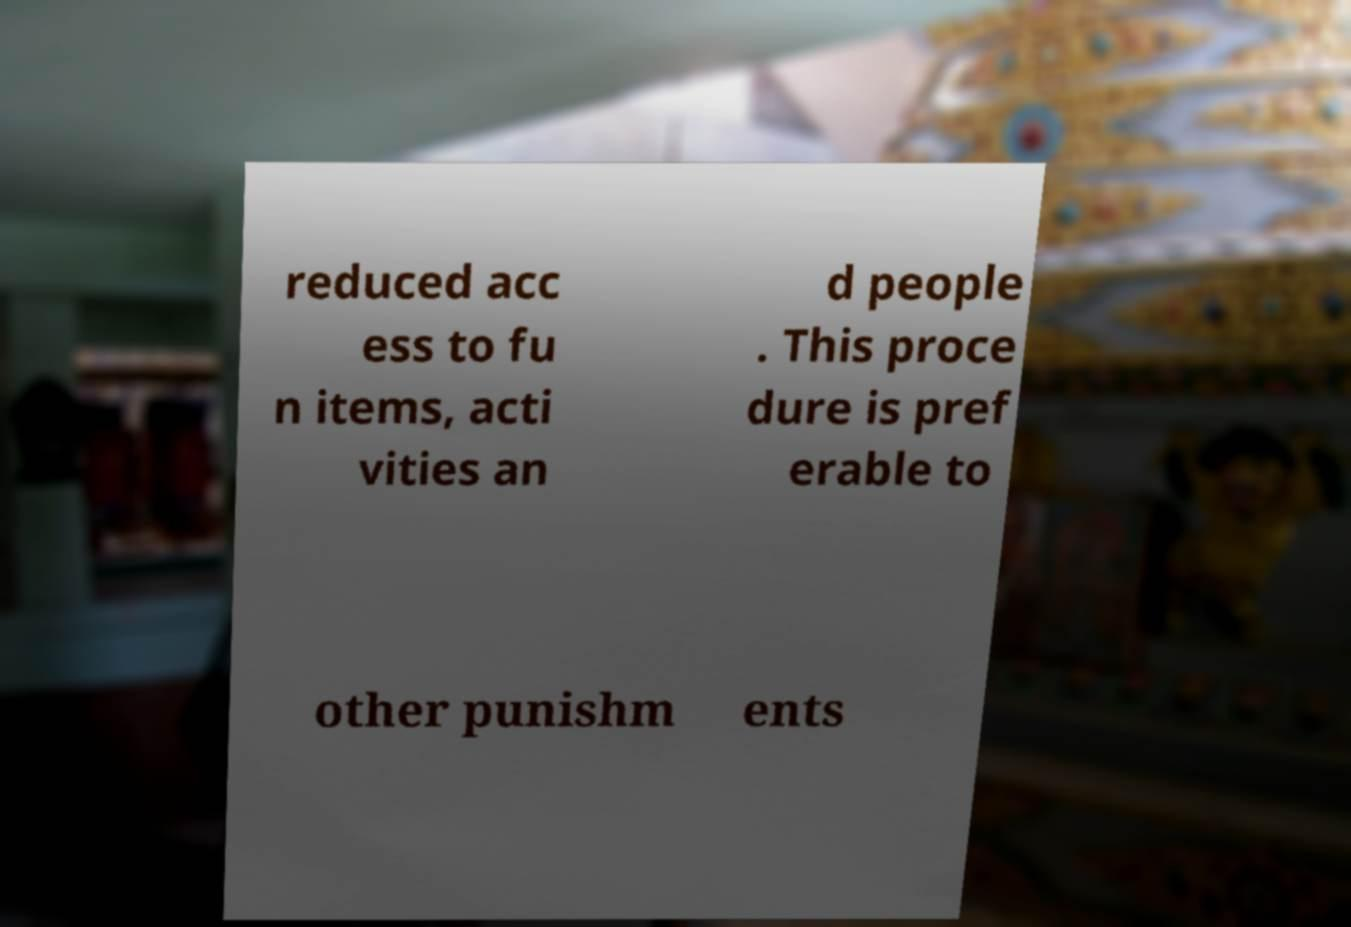Could you assist in decoding the text presented in this image and type it out clearly? reduced acc ess to fu n items, acti vities an d people . This proce dure is pref erable to other punishm ents 